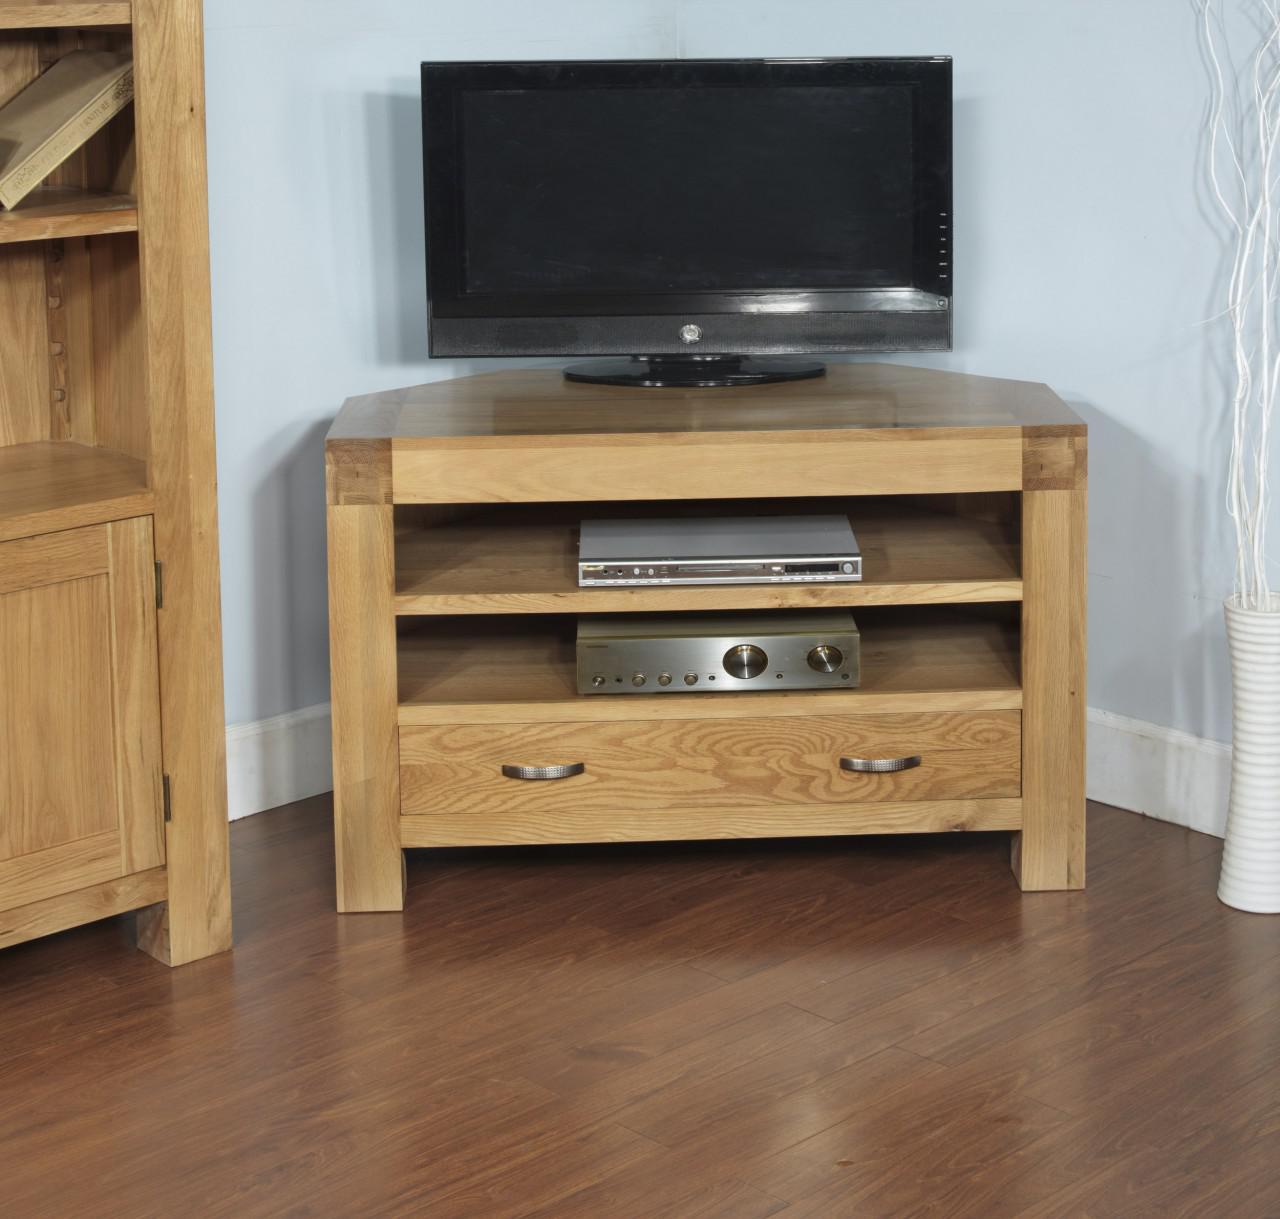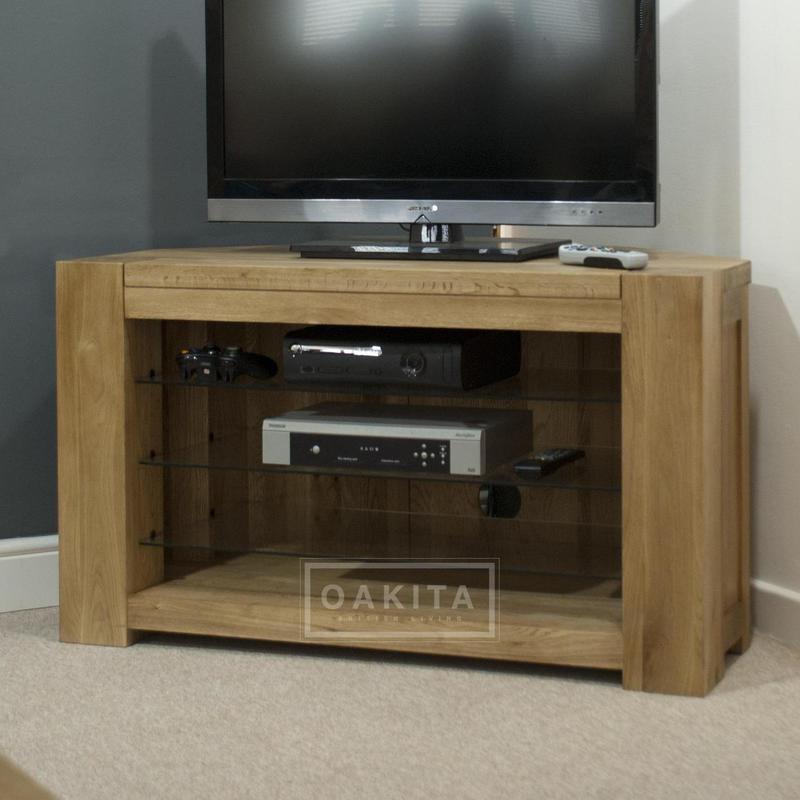The first image is the image on the left, the second image is the image on the right. Considering the images on both sides, is "The legs of one media stand is made of metal." valid? Answer yes or no. No. 